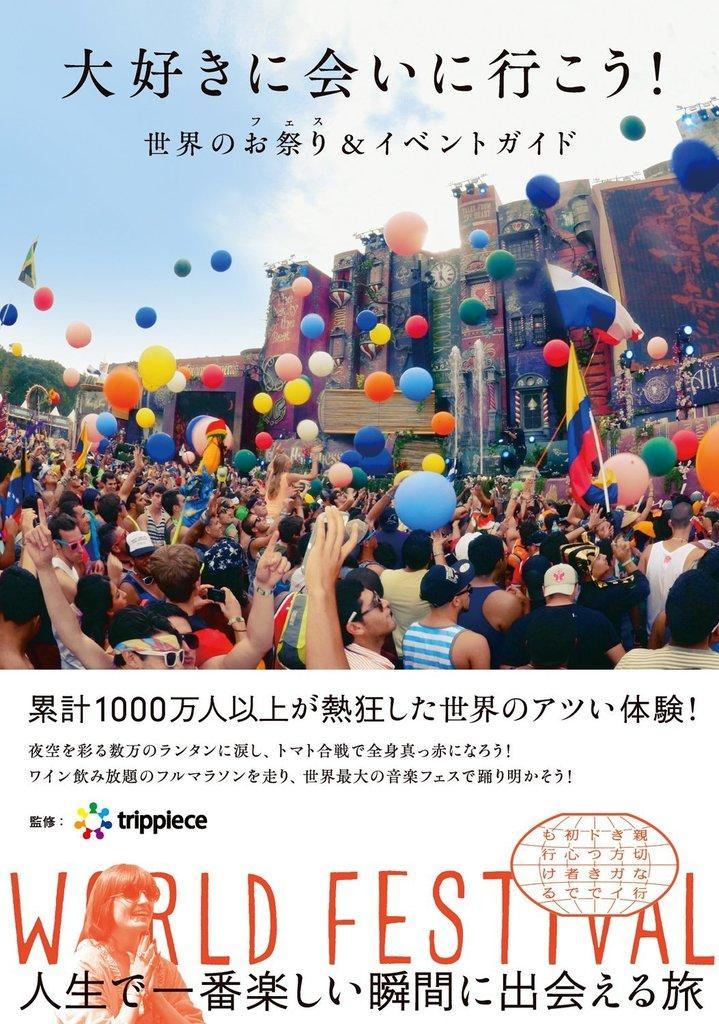Can you describe this image briefly? In this image we can see a poster. In the poster we can see a group of persons and the balloons. Behind the persons we can see the buildings. On the right side, we can see a banner on the building. At the top we can see the sky and the text. At the bottom we can see an image of a person and the text. 